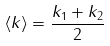Convert formula to latex. <formula><loc_0><loc_0><loc_500><loc_500>\langle k \rangle = \frac { k _ { 1 } + k _ { 2 } } { 2 }</formula> 